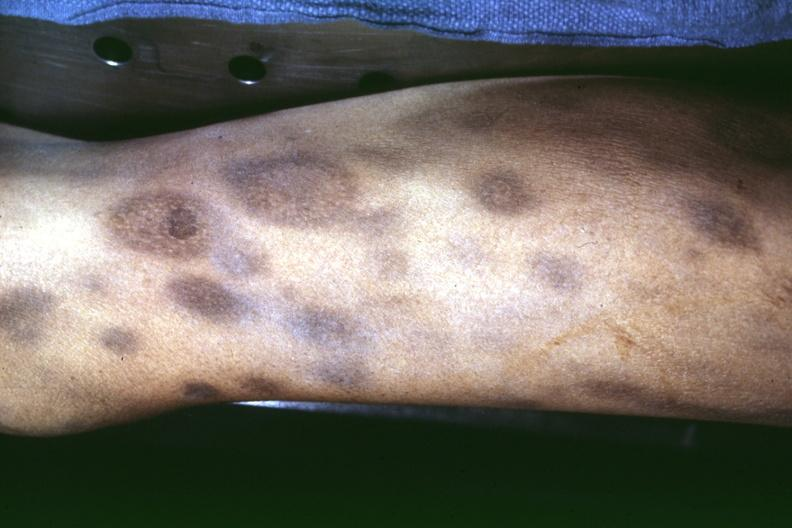what ecchymoses with necrotic appearing centers looks like pyoderma gangrenosum?
Answer the question using a single word or phrase. External view of knee at autopsy 